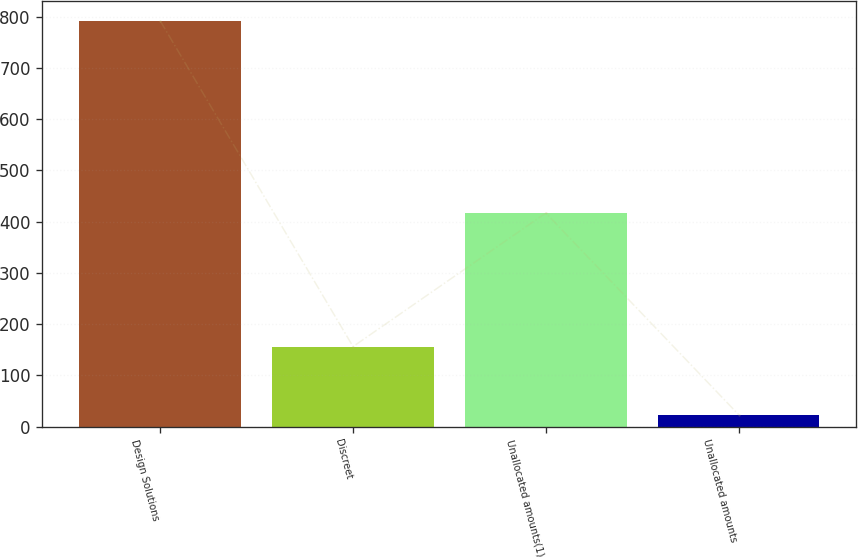Convert chart. <chart><loc_0><loc_0><loc_500><loc_500><bar_chart><fcel>Design Solutions<fcel>Discreet<fcel>Unallocated amounts(1)<fcel>Unallocated amounts<nl><fcel>791.4<fcel>156.1<fcel>416.7<fcel>23.4<nl></chart> 